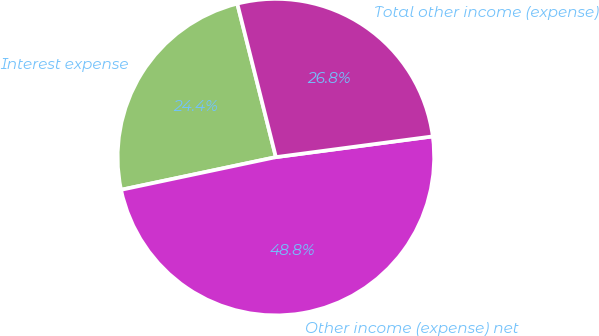Convert chart to OTSL. <chart><loc_0><loc_0><loc_500><loc_500><pie_chart><fcel>Interest expense<fcel>Other income (expense) net<fcel>Total other income (expense)<nl><fcel>24.39%<fcel>48.78%<fcel>26.83%<nl></chart> 